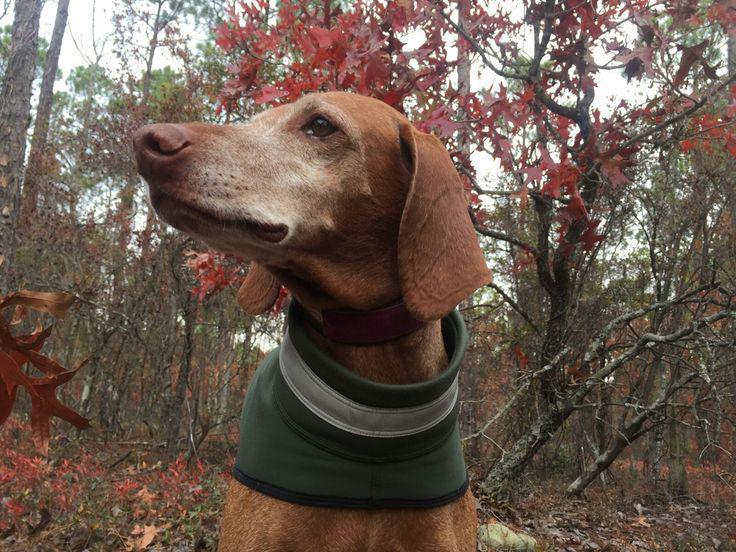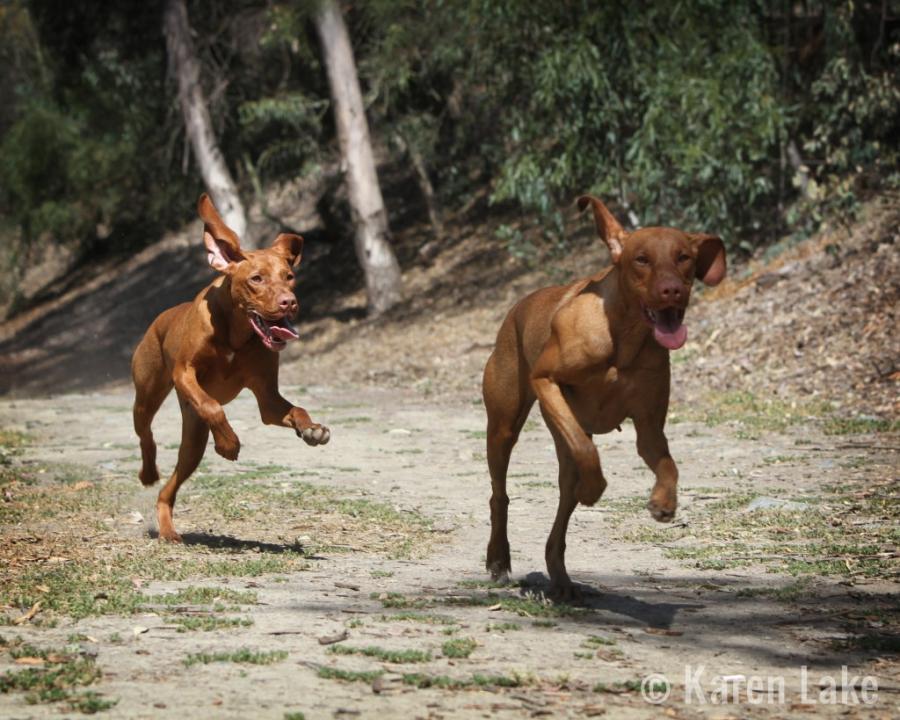The first image is the image on the left, the second image is the image on the right. Assess this claim about the two images: "There is three dogs.". Correct or not? Answer yes or no. Yes. The first image is the image on the left, the second image is the image on the right. Considering the images on both sides, is "In one image, a red-orange dog in a collar with a leash attached stands on a high rock perch gazing." valid? Answer yes or no. No. 